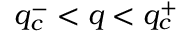Convert formula to latex. <formula><loc_0><loc_0><loc_500><loc_500>q _ { c } ^ { - } < q < q _ { c } ^ { + }</formula> 